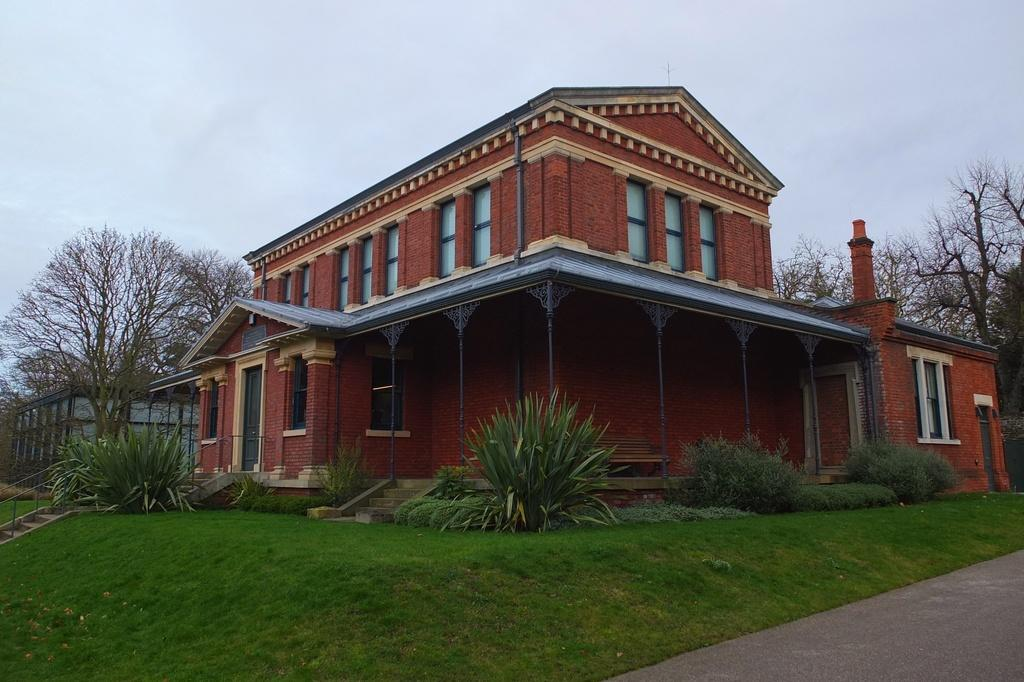What is the main structure in the center of the image? There is a building in the center of the image. What type of vegetation can be seen in the background of the image? There are trees in the background. What type of plants are at the bottom of the image? There are bushes and grass at the bottom. What is visible at the top of the image? The sky is visible at the top. How many arches are present on the bed in the image? There is no bed present in the image, so it is not possible to determine the number of arches on it. 